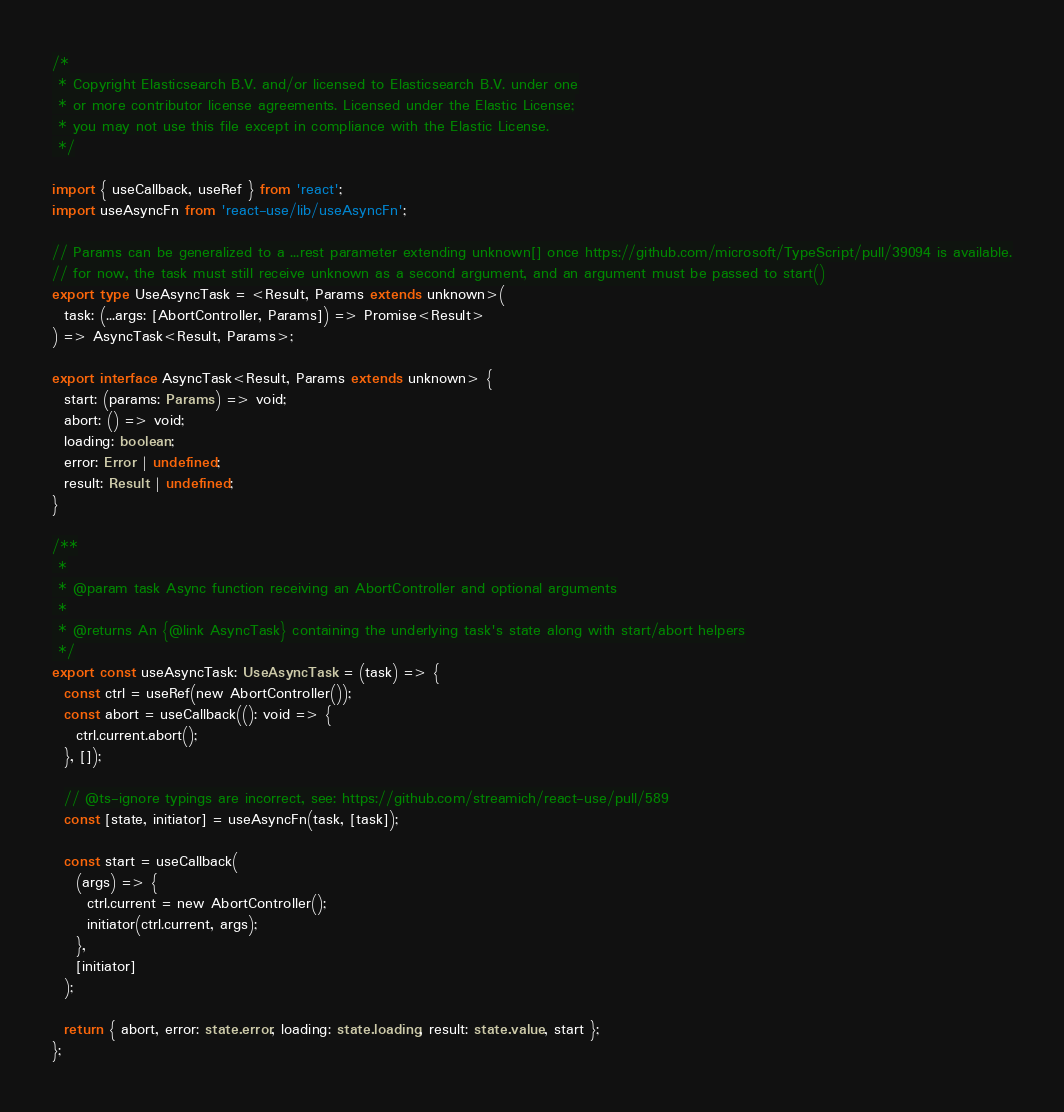Convert code to text. <code><loc_0><loc_0><loc_500><loc_500><_TypeScript_>/*
 * Copyright Elasticsearch B.V. and/or licensed to Elasticsearch B.V. under one
 * or more contributor license agreements. Licensed under the Elastic License;
 * you may not use this file except in compliance with the Elastic License.
 */

import { useCallback, useRef } from 'react';
import useAsyncFn from 'react-use/lib/useAsyncFn';

// Params can be generalized to a ...rest parameter extending unknown[] once https://github.com/microsoft/TypeScript/pull/39094 is available.
// for now, the task must still receive unknown as a second argument, and an argument must be passed to start()
export type UseAsyncTask = <Result, Params extends unknown>(
  task: (...args: [AbortController, Params]) => Promise<Result>
) => AsyncTask<Result, Params>;

export interface AsyncTask<Result, Params extends unknown> {
  start: (params: Params) => void;
  abort: () => void;
  loading: boolean;
  error: Error | undefined;
  result: Result | undefined;
}

/**
 *
 * @param task Async function receiving an AbortController and optional arguments
 *
 * @returns An {@link AsyncTask} containing the underlying task's state along with start/abort helpers
 */
export const useAsyncTask: UseAsyncTask = (task) => {
  const ctrl = useRef(new AbortController());
  const abort = useCallback((): void => {
    ctrl.current.abort();
  }, []);

  // @ts-ignore typings are incorrect, see: https://github.com/streamich/react-use/pull/589
  const [state, initiator] = useAsyncFn(task, [task]);

  const start = useCallback(
    (args) => {
      ctrl.current = new AbortController();
      initiator(ctrl.current, args);
    },
    [initiator]
  );

  return { abort, error: state.error, loading: state.loading, result: state.value, start };
};
</code> 